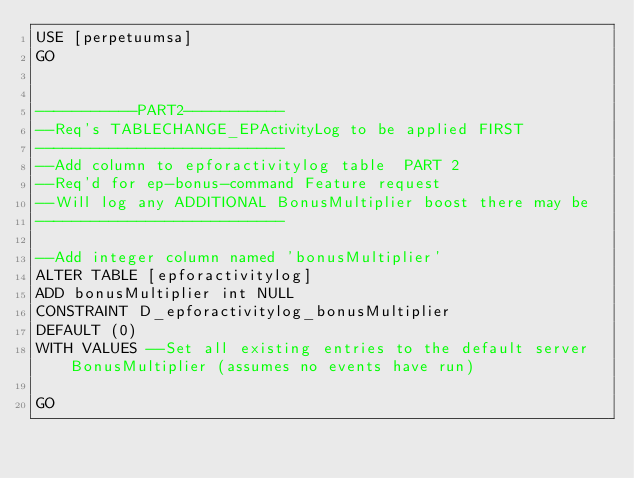<code> <loc_0><loc_0><loc_500><loc_500><_SQL_>USE [perpetuumsa]
GO


-----------PART2-----------
--Req's TABLECHANGE_EPActivityLog to be applied FIRST
---------------------------
--Add column to epforactivitylog table  PART 2
--Req'd for ep-bonus-command Feature request
--Will log any ADDITIONAL BonusMultiplier boost there may be
---------------------------

--Add integer column named 'bonusMultiplier'
ALTER TABLE [epforactivitylog]
ADD bonusMultiplier int NULL
CONSTRAINT D_epforactivitylog_bonusMultiplier
DEFAULT (0)
WITH VALUES --Set all existing entries to the default server BonusMultiplier (assumes no events have run)

GO


</code> 